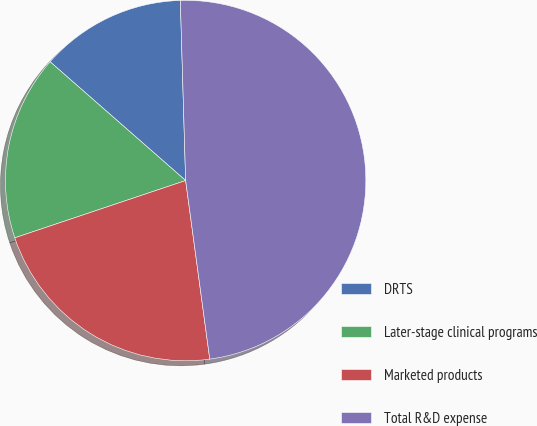Convert chart. <chart><loc_0><loc_0><loc_500><loc_500><pie_chart><fcel>DRTS<fcel>Later-stage clinical programs<fcel>Marketed products<fcel>Total R&D expense<nl><fcel>13.08%<fcel>16.6%<fcel>21.99%<fcel>48.33%<nl></chart> 